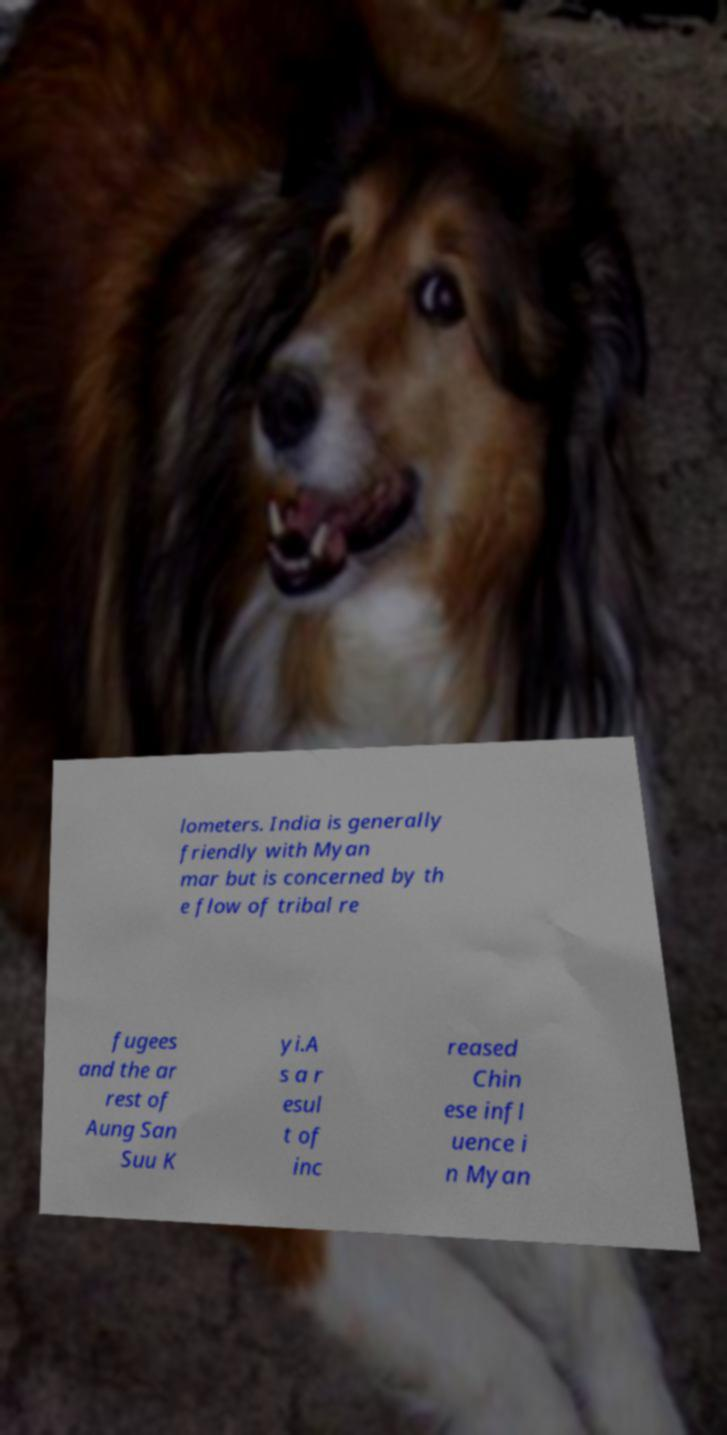Please read and relay the text visible in this image. What does it say? lometers. India is generally friendly with Myan mar but is concerned by th e flow of tribal re fugees and the ar rest of Aung San Suu K yi.A s a r esul t of inc reased Chin ese infl uence i n Myan 